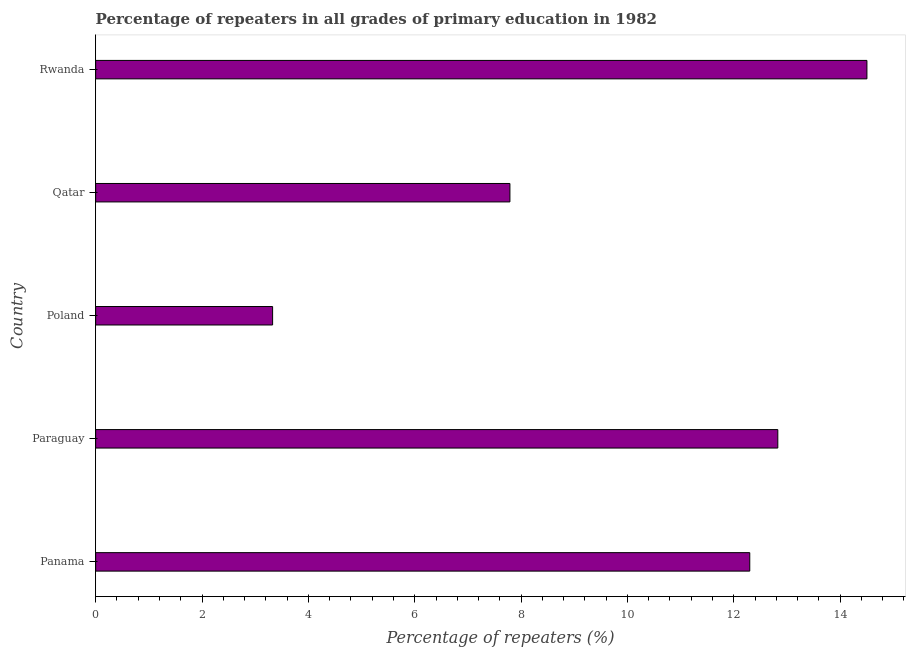Does the graph contain any zero values?
Provide a short and direct response. No. Does the graph contain grids?
Make the answer very short. No. What is the title of the graph?
Offer a terse response. Percentage of repeaters in all grades of primary education in 1982. What is the label or title of the X-axis?
Keep it short and to the point. Percentage of repeaters (%). What is the percentage of repeaters in primary education in Rwanda?
Make the answer very short. 14.5. Across all countries, what is the maximum percentage of repeaters in primary education?
Give a very brief answer. 14.5. Across all countries, what is the minimum percentage of repeaters in primary education?
Make the answer very short. 3.33. In which country was the percentage of repeaters in primary education maximum?
Provide a short and direct response. Rwanda. What is the sum of the percentage of repeaters in primary education?
Your answer should be very brief. 50.75. What is the difference between the percentage of repeaters in primary education in Paraguay and Qatar?
Ensure brevity in your answer.  5.04. What is the average percentage of repeaters in primary education per country?
Keep it short and to the point. 10.15. What is the median percentage of repeaters in primary education?
Provide a succinct answer. 12.3. What is the ratio of the percentage of repeaters in primary education in Paraguay to that in Poland?
Offer a terse response. 3.85. What is the difference between the highest and the second highest percentage of repeaters in primary education?
Make the answer very short. 1.68. Is the sum of the percentage of repeaters in primary education in Panama and Poland greater than the maximum percentage of repeaters in primary education across all countries?
Your answer should be very brief. Yes. What is the difference between the highest and the lowest percentage of repeaters in primary education?
Your answer should be very brief. 11.18. In how many countries, is the percentage of repeaters in primary education greater than the average percentage of repeaters in primary education taken over all countries?
Your answer should be compact. 3. How many countries are there in the graph?
Your response must be concise. 5. What is the difference between two consecutive major ticks on the X-axis?
Your answer should be very brief. 2. Are the values on the major ticks of X-axis written in scientific E-notation?
Make the answer very short. No. What is the Percentage of repeaters (%) of Panama?
Your response must be concise. 12.3. What is the Percentage of repeaters (%) in Paraguay?
Your answer should be very brief. 12.83. What is the Percentage of repeaters (%) of Poland?
Your response must be concise. 3.33. What is the Percentage of repeaters (%) in Qatar?
Provide a succinct answer. 7.79. What is the Percentage of repeaters (%) of Rwanda?
Provide a short and direct response. 14.5. What is the difference between the Percentage of repeaters (%) in Panama and Paraguay?
Provide a short and direct response. -0.53. What is the difference between the Percentage of repeaters (%) in Panama and Poland?
Ensure brevity in your answer.  8.97. What is the difference between the Percentage of repeaters (%) in Panama and Qatar?
Your answer should be very brief. 4.51. What is the difference between the Percentage of repeaters (%) in Panama and Rwanda?
Provide a succinct answer. -2.2. What is the difference between the Percentage of repeaters (%) in Paraguay and Poland?
Offer a terse response. 9.5. What is the difference between the Percentage of repeaters (%) in Paraguay and Qatar?
Your response must be concise. 5.04. What is the difference between the Percentage of repeaters (%) in Paraguay and Rwanda?
Your response must be concise. -1.68. What is the difference between the Percentage of repeaters (%) in Poland and Qatar?
Provide a succinct answer. -4.46. What is the difference between the Percentage of repeaters (%) in Poland and Rwanda?
Ensure brevity in your answer.  -11.18. What is the difference between the Percentage of repeaters (%) in Qatar and Rwanda?
Give a very brief answer. -6.71. What is the ratio of the Percentage of repeaters (%) in Panama to that in Paraguay?
Make the answer very short. 0.96. What is the ratio of the Percentage of repeaters (%) in Panama to that in Poland?
Offer a terse response. 3.7. What is the ratio of the Percentage of repeaters (%) in Panama to that in Qatar?
Keep it short and to the point. 1.58. What is the ratio of the Percentage of repeaters (%) in Panama to that in Rwanda?
Your response must be concise. 0.85. What is the ratio of the Percentage of repeaters (%) in Paraguay to that in Poland?
Keep it short and to the point. 3.85. What is the ratio of the Percentage of repeaters (%) in Paraguay to that in Qatar?
Give a very brief answer. 1.65. What is the ratio of the Percentage of repeaters (%) in Paraguay to that in Rwanda?
Ensure brevity in your answer.  0.88. What is the ratio of the Percentage of repeaters (%) in Poland to that in Qatar?
Provide a succinct answer. 0.43. What is the ratio of the Percentage of repeaters (%) in Poland to that in Rwanda?
Give a very brief answer. 0.23. What is the ratio of the Percentage of repeaters (%) in Qatar to that in Rwanda?
Offer a terse response. 0.54. 